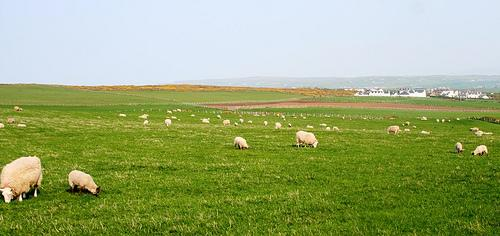In one sentence, quickly explain the most significant visual elements of the image. Various sheep feed on a colorful grass field, surrounded by mountains, buildings, and a blue sky. Create a brief title or tagline for the image, stressing the primary subject and their environment. "Grazing in Serenity - Sheep on a Picturesque Pasture" Imagine you are describing the image to someone who cannot see it - mention essential details that convey the essence of the picture. The image shows sheep of varying colors grazing on a mixed green and yellow grass field, with mountains and buildings in the distance, under a blue sky. List some prominent aspects of the image, such as the primary subject, their environment, and any notable structures. Sheep grazing, green and yellow grass, mountains, few buildings, and blue sky. Mention the key visual elements in the image, focusing on the main subjects and their actions. Sheep grazing in a field with green and yellow grass, mountains in the background, buildings nearby, and a clear blue sky above. Choose three key attributes of the image, including the main subject, and compose a brief description. Sheep grazing on a colorful pasture, with distant mountains, and a clear blue sky. Write a short sentence expressing the main activity happening in the image. Flock of sheep munching on grass in a picturesque pasture setting. Mention the central focus of the image, any secondary subjects, and their interactions with the surroundings. Grazing sheep as the main focus, with differences in color, mountains and buildings in the background, and a blue sky overhead. Using simple words, describe the major elements of the image, highlighting the main subjects and the setting. In the picture, there are sheep eating grass, colorful pasture, mountains far away, some buildings, and a nice blue sky. Write a brief description of the scene in the image, paying attention to the main actors and their surroundings. A flock of sheep, including some with white and black faces, graze on a pasture with green and yellow grass, with buildings and mountains in the distance, under a blue sky. 